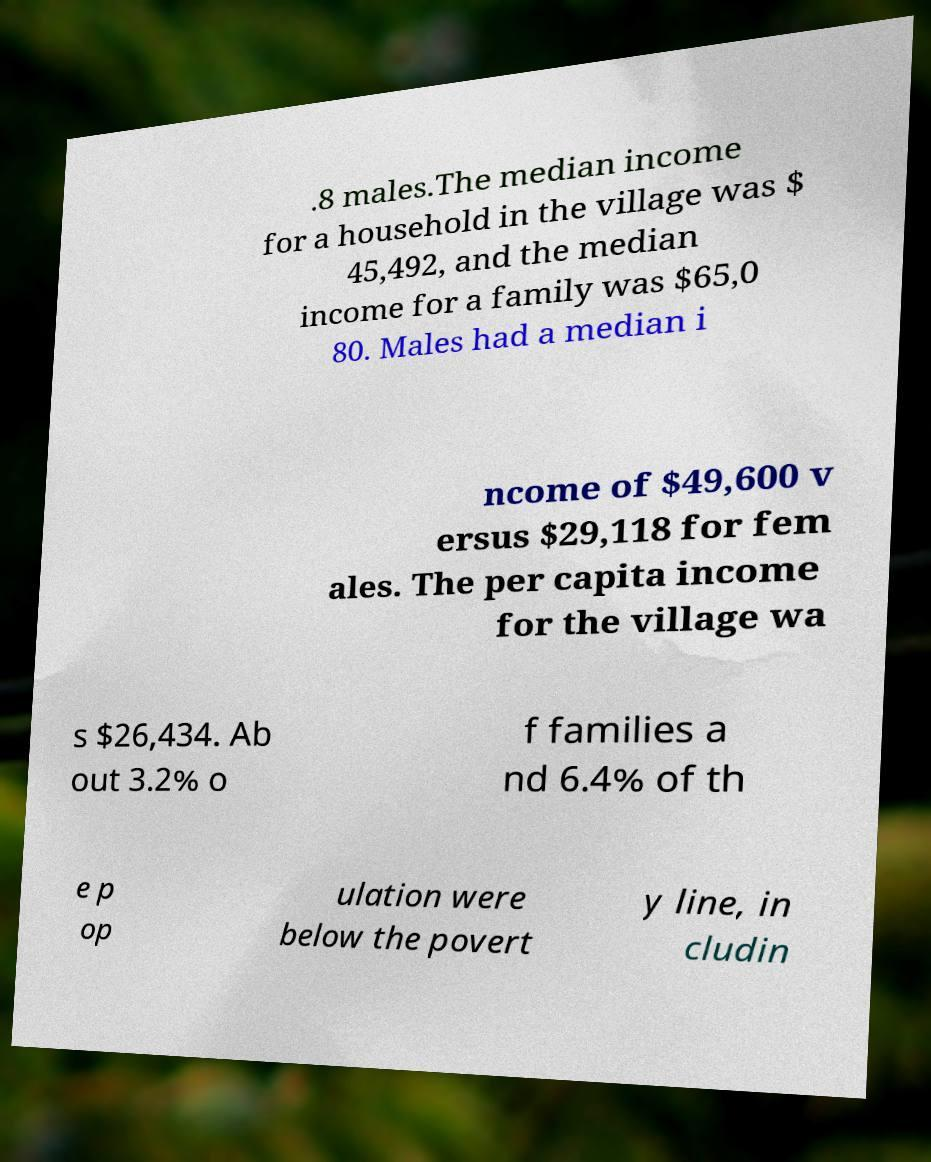Can you accurately transcribe the text from the provided image for me? .8 males.The median income for a household in the village was $ 45,492, and the median income for a family was $65,0 80. Males had a median i ncome of $49,600 v ersus $29,118 for fem ales. The per capita income for the village wa s $26,434. Ab out 3.2% o f families a nd 6.4% of th e p op ulation were below the povert y line, in cludin 